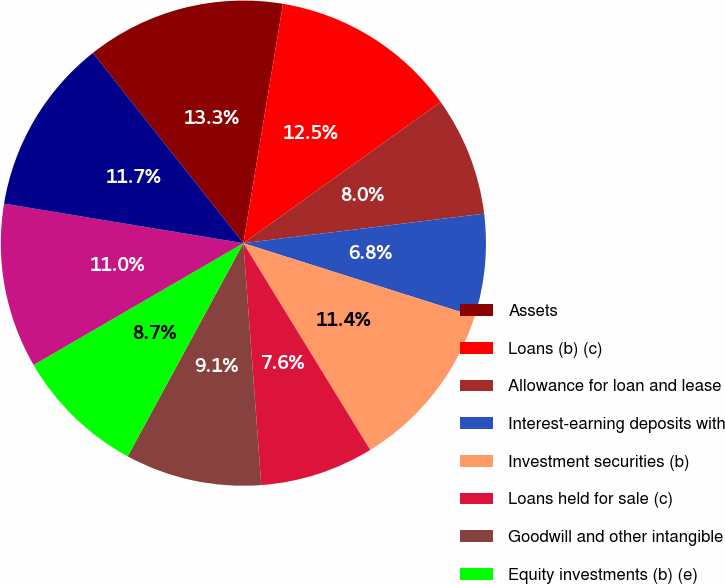<chart> <loc_0><loc_0><loc_500><loc_500><pie_chart><fcel>Assets<fcel>Loans (b) (c)<fcel>Allowance for loan and lease<fcel>Interest-earning deposits with<fcel>Investment securities (b)<fcel>Loans held for sale (c)<fcel>Goodwill and other intangible<fcel>Equity investments (b) (e)<fcel>Noninterest-bearing deposits<fcel>Interest-bearing deposits<nl><fcel>13.26%<fcel>12.5%<fcel>7.95%<fcel>6.82%<fcel>11.36%<fcel>7.58%<fcel>9.09%<fcel>8.71%<fcel>10.98%<fcel>11.74%<nl></chart> 